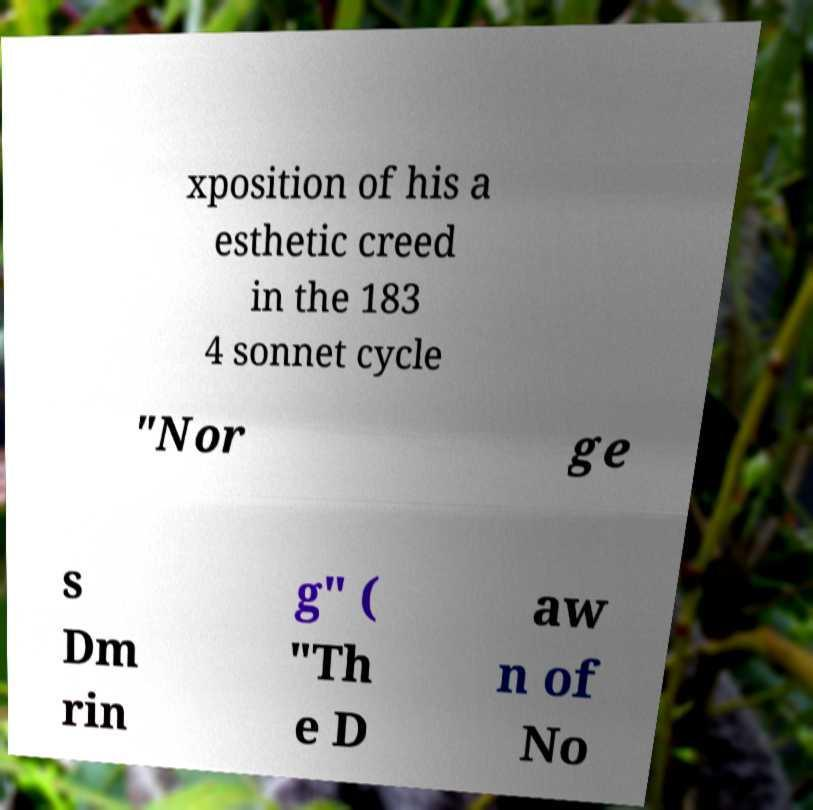Can you accurately transcribe the text from the provided image for me? xposition of his a esthetic creed in the 183 4 sonnet cycle "Nor ge s Dm rin g" ( "Th e D aw n of No 